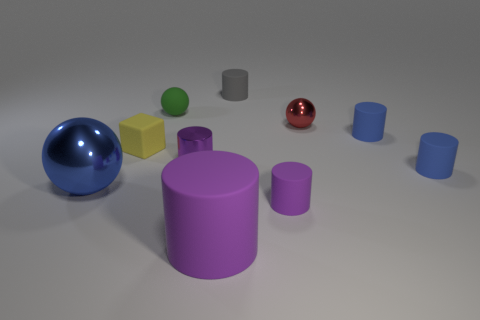Subtract all purple cylinders. How many were subtracted if there are1purple cylinders left? 2 Subtract all blue spheres. How many purple cylinders are left? 3 Subtract all gray cylinders. How many cylinders are left? 5 Subtract all large cylinders. How many cylinders are left? 5 Subtract all purple balls. Subtract all cyan blocks. How many balls are left? 3 Subtract all balls. How many objects are left? 7 Add 8 gray matte things. How many gray matte things are left? 9 Add 8 small purple blocks. How many small purple blocks exist? 8 Subtract 0 green cylinders. How many objects are left? 10 Subtract all large red matte blocks. Subtract all red objects. How many objects are left? 9 